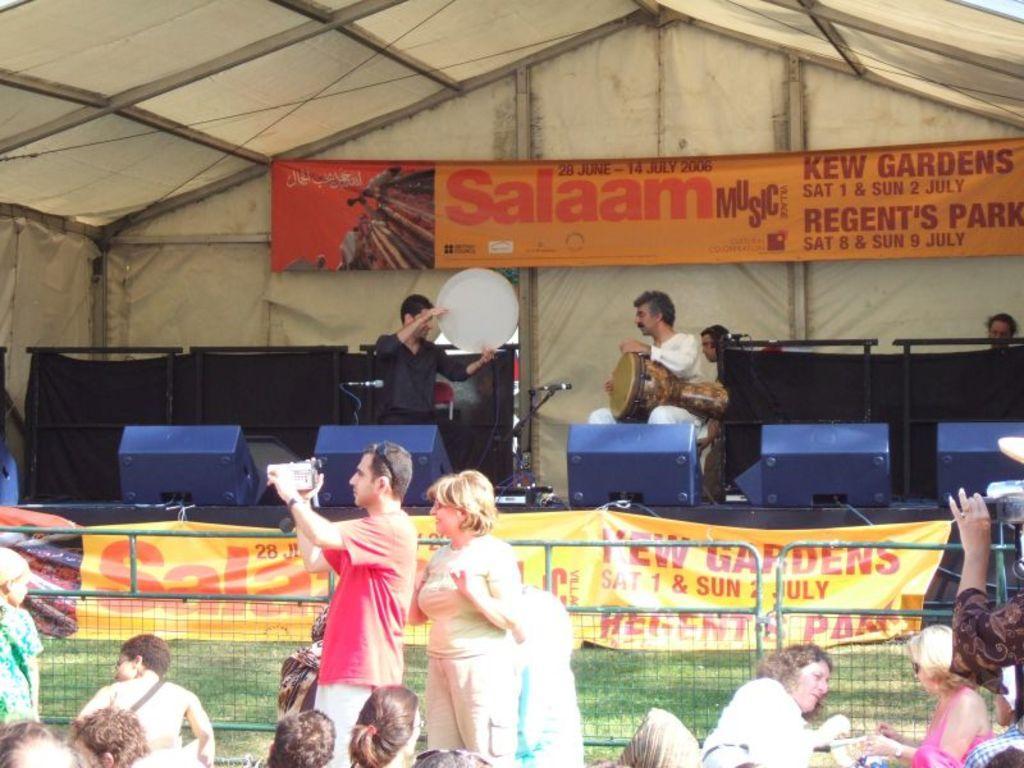Describe this image in one or two sentences. In this picture we can see two people standing on stage and the man on the right side is holding on musical instrument and in the bottom we can see a barricades and the person standing one man is capturing video from his camera, at the top of the picture we can see a banner, in the bottom of them there are some group of people. 